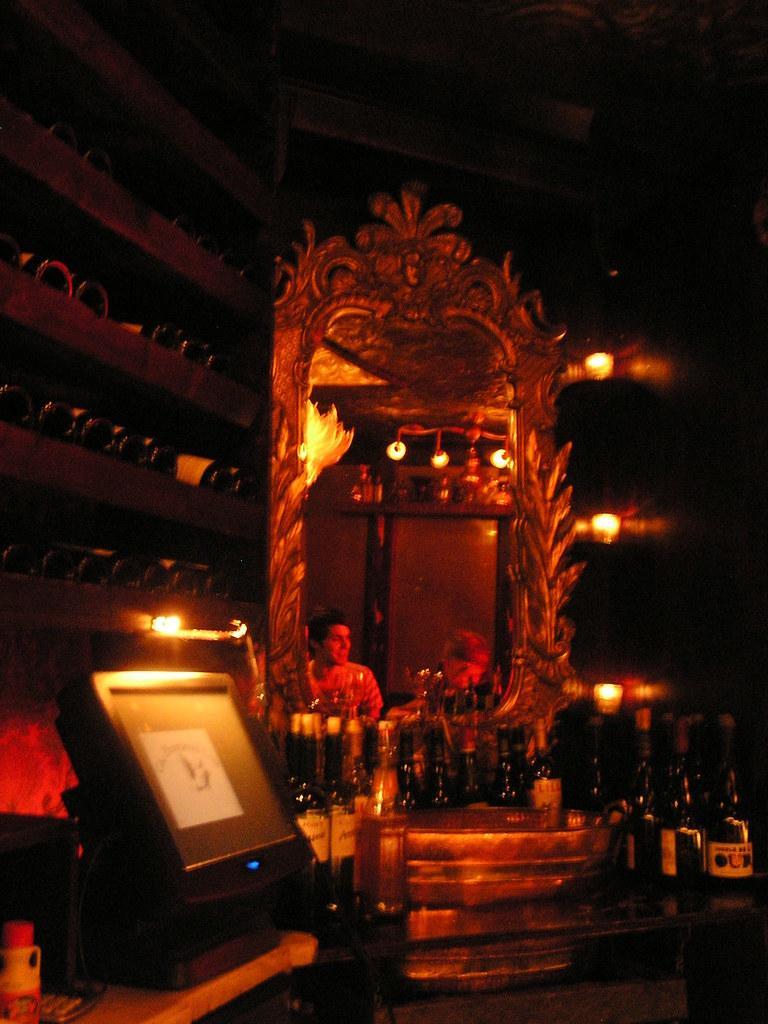Can you describe this image briefly? In this image, we can see a mirror and the reflection of people in the mirror. We can see a few bottles on the surface. We can also see a screen and some objects on the left. We can see some shelves with objects. We can also see the dark background. 